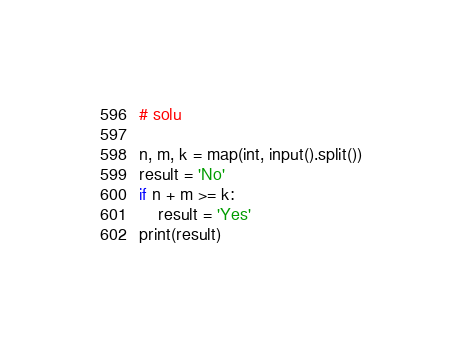Convert code to text. <code><loc_0><loc_0><loc_500><loc_500><_Python_># solu

n, m, k = map(int, input().split())
result = 'No'
if n + m >= k:
    result = 'Yes'
print(result)</code> 